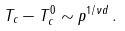Convert formula to latex. <formula><loc_0><loc_0><loc_500><loc_500>T _ { c } - T _ { c } ^ { 0 } \sim p ^ { 1 / \nu d } \, .</formula> 